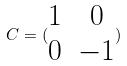<formula> <loc_0><loc_0><loc_500><loc_500>C = ( \begin{matrix} 1 & 0 \\ 0 & - 1 \end{matrix} )</formula> 